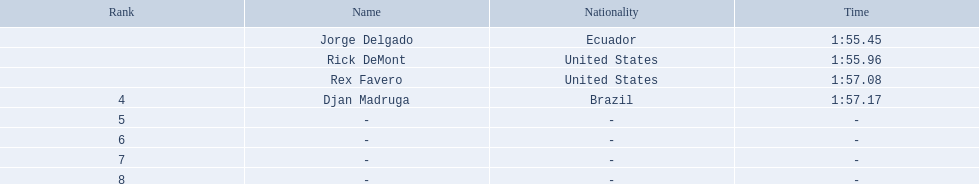Who ended with the top duration? Jorge Delgado. 